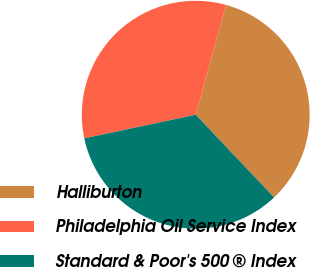<chart> <loc_0><loc_0><loc_500><loc_500><pie_chart><fcel>Halliburton<fcel>Philadelphia Oil Service Index<fcel>Standard & Poor's 500 ® Index<nl><fcel>33.64%<fcel>32.61%<fcel>33.75%<nl></chart> 